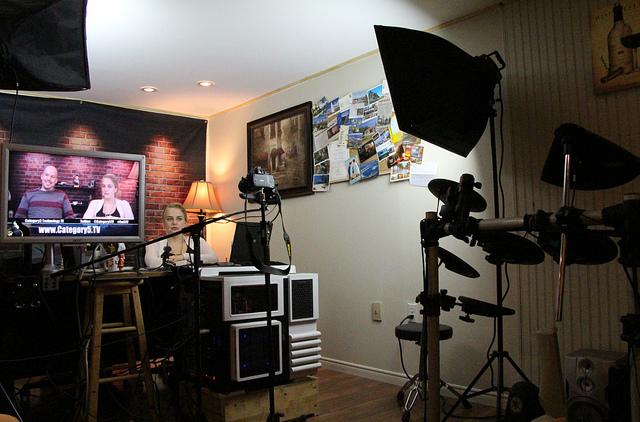How many people can be seen on the screen?
Write a very short answer. 2. Is there a TV on?
Keep it brief. Yes. What is posted on the corkboard?
Quick response, please. Pictures. 